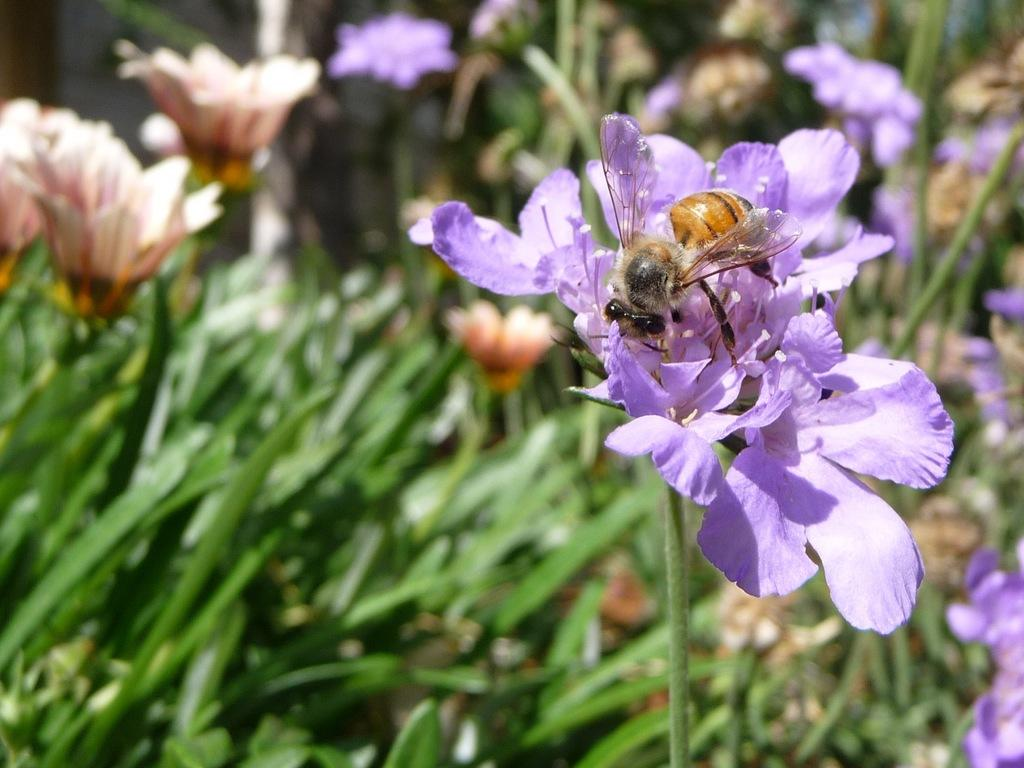What is on the flower in the image? There is an insect on a flower in the image. What can be seen in the background of the image? There are plants with flowers in the background of the image. What type of gun is being used to harvest the oranges in the image? There are no oranges or guns present in the image; it features an insect on a flower and plants with flowers in the background. 